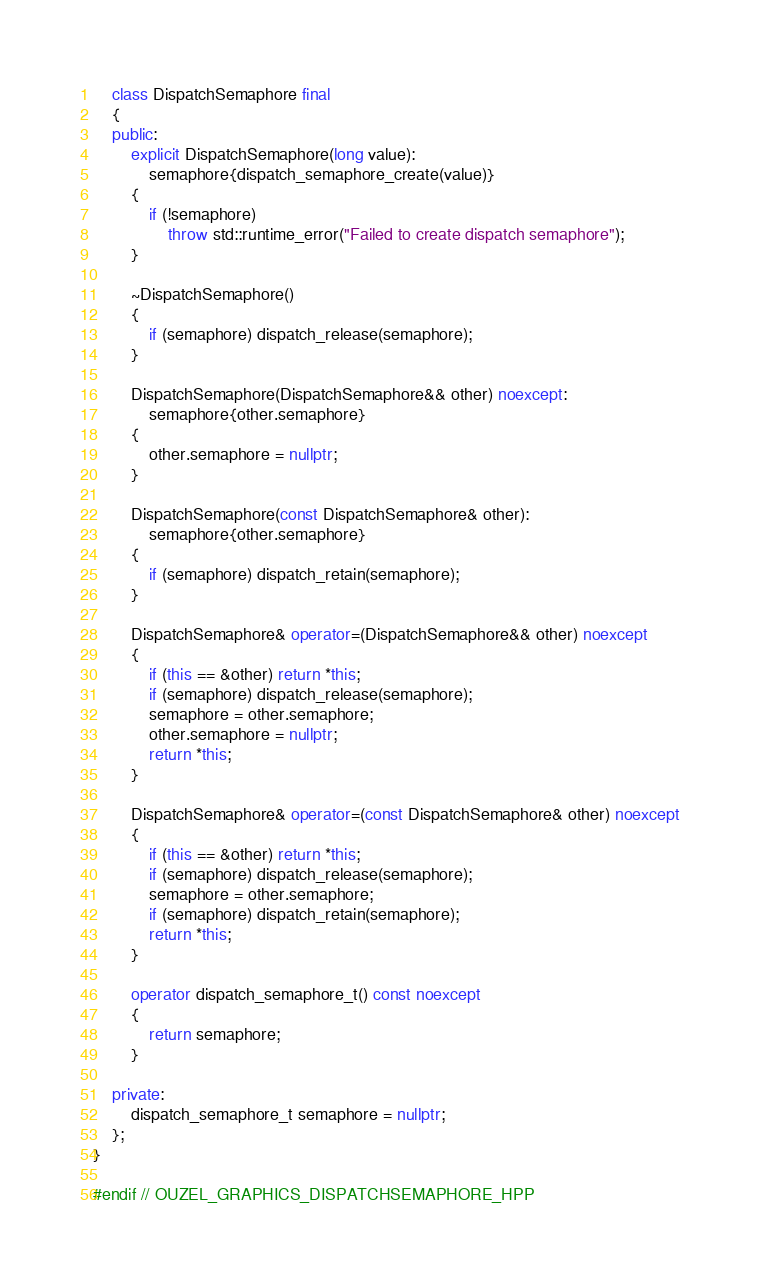<code> <loc_0><loc_0><loc_500><loc_500><_C++_>    class DispatchSemaphore final
    {
    public:
        explicit DispatchSemaphore(long value):
            semaphore{dispatch_semaphore_create(value)}
        {
            if (!semaphore)
                throw std::runtime_error("Failed to create dispatch semaphore");
        }

        ~DispatchSemaphore()
        {
            if (semaphore) dispatch_release(semaphore);
        }

        DispatchSemaphore(DispatchSemaphore&& other) noexcept:
            semaphore{other.semaphore}
        {
            other.semaphore = nullptr;
        }

        DispatchSemaphore(const DispatchSemaphore& other):
            semaphore{other.semaphore}
        {
            if (semaphore) dispatch_retain(semaphore);
        }

        DispatchSemaphore& operator=(DispatchSemaphore&& other) noexcept
        {
            if (this == &other) return *this;
            if (semaphore) dispatch_release(semaphore);
            semaphore = other.semaphore;
            other.semaphore = nullptr;
            return *this;
        }

        DispatchSemaphore& operator=(const DispatchSemaphore& other) noexcept
        {
            if (this == &other) return *this;
            if (semaphore) dispatch_release(semaphore);
            semaphore = other.semaphore;
            if (semaphore) dispatch_retain(semaphore);
            return *this;
        }

        operator dispatch_semaphore_t() const noexcept
        {
            return semaphore;
        }

    private:
        dispatch_semaphore_t semaphore = nullptr;
    };
}

#endif // OUZEL_GRAPHICS_DISPATCHSEMAPHORE_HPP
</code> 